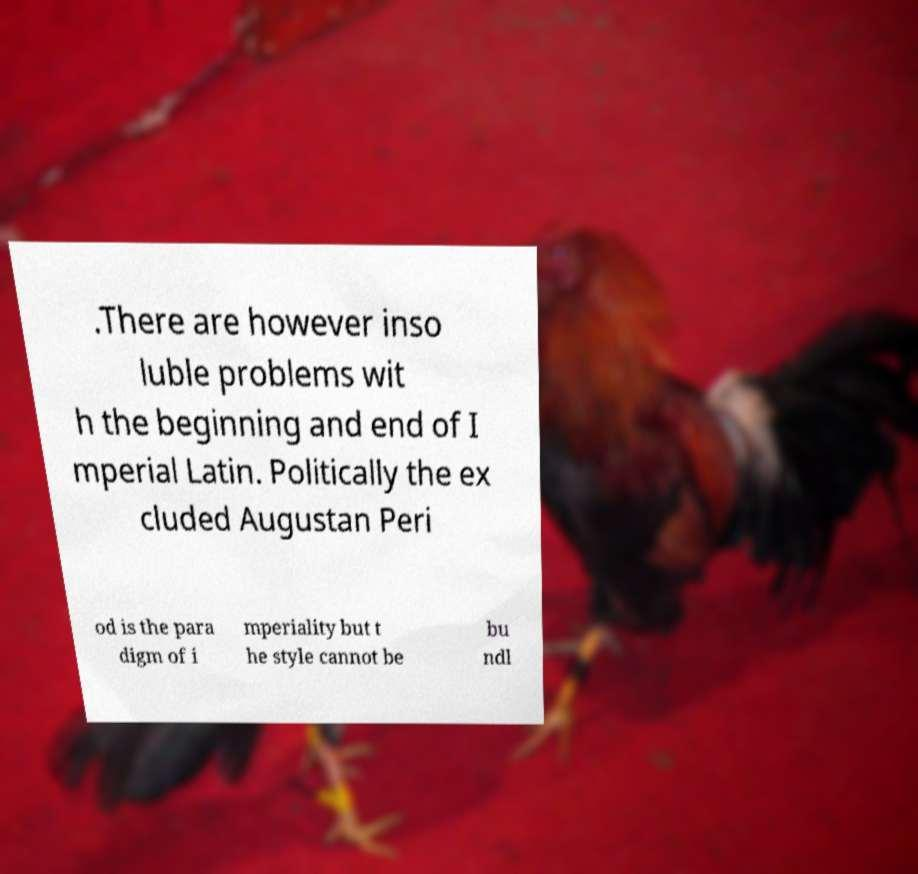Can you accurately transcribe the text from the provided image for me? .There are however inso luble problems wit h the beginning and end of I mperial Latin. Politically the ex cluded Augustan Peri od is the para digm of i mperiality but t he style cannot be bu ndl 